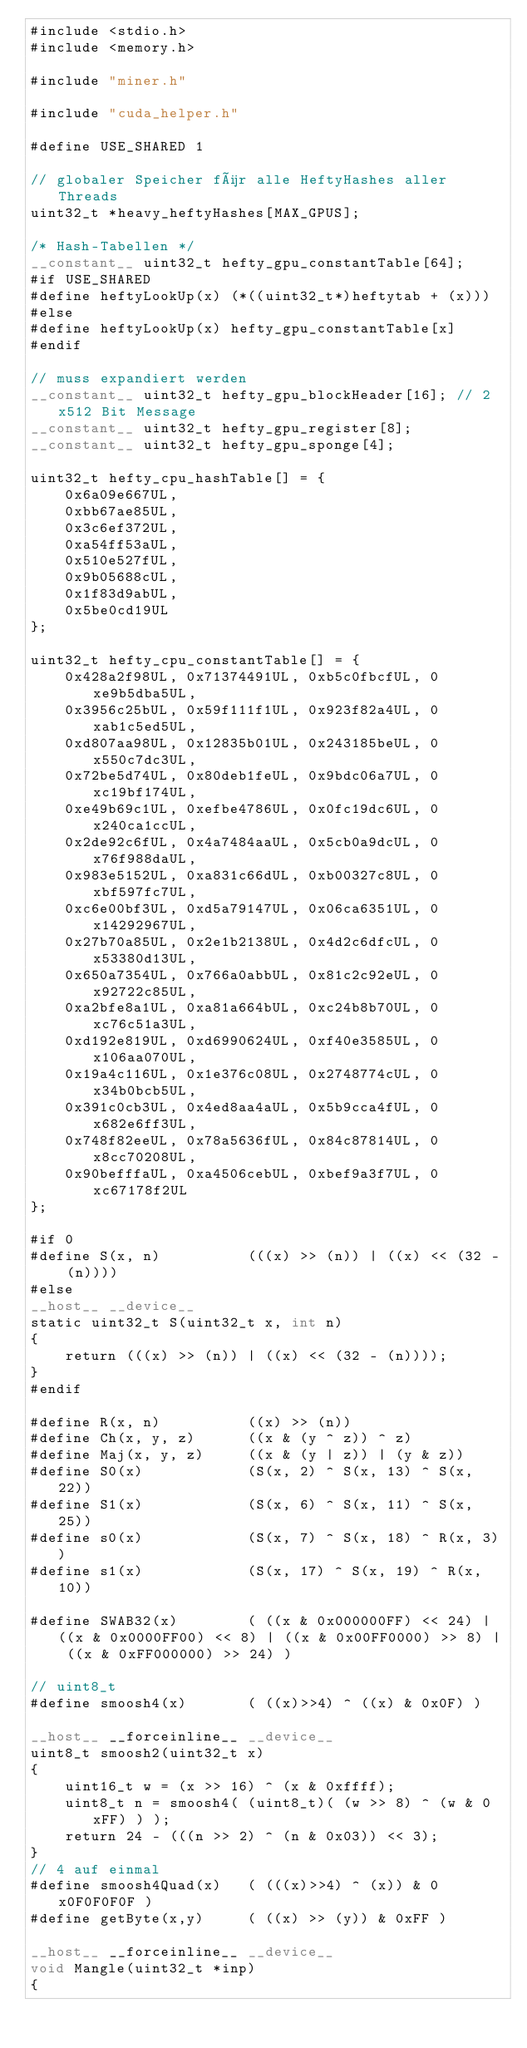<code> <loc_0><loc_0><loc_500><loc_500><_Cuda_>#include <stdio.h>
#include <memory.h>

#include "miner.h"

#include "cuda_helper.h"

#define USE_SHARED 1

// globaler Speicher für alle HeftyHashes aller Threads
uint32_t *heavy_heftyHashes[MAX_GPUS];

/* Hash-Tabellen */
__constant__ uint32_t hefty_gpu_constantTable[64];
#if USE_SHARED
#define heftyLookUp(x) (*((uint32_t*)heftytab + (x)))
#else
#define heftyLookUp(x) hefty_gpu_constantTable[x]
#endif

// muss expandiert werden
__constant__ uint32_t hefty_gpu_blockHeader[16]; // 2x512 Bit Message
__constant__ uint32_t hefty_gpu_register[8];
__constant__ uint32_t hefty_gpu_sponge[4];

uint32_t hefty_cpu_hashTable[] = {
    0x6a09e667UL,
    0xbb67ae85UL,
    0x3c6ef372UL,
    0xa54ff53aUL,
    0x510e527fUL,
    0x9b05688cUL,
    0x1f83d9abUL,
    0x5be0cd19UL
};

uint32_t hefty_cpu_constantTable[] = {
    0x428a2f98UL, 0x71374491UL, 0xb5c0fbcfUL, 0xe9b5dba5UL,
    0x3956c25bUL, 0x59f111f1UL, 0x923f82a4UL, 0xab1c5ed5UL,
    0xd807aa98UL, 0x12835b01UL, 0x243185beUL, 0x550c7dc3UL,
    0x72be5d74UL, 0x80deb1feUL, 0x9bdc06a7UL, 0xc19bf174UL,
    0xe49b69c1UL, 0xefbe4786UL, 0x0fc19dc6UL, 0x240ca1ccUL,
    0x2de92c6fUL, 0x4a7484aaUL, 0x5cb0a9dcUL, 0x76f988daUL,
    0x983e5152UL, 0xa831c66dUL, 0xb00327c8UL, 0xbf597fc7UL,
    0xc6e00bf3UL, 0xd5a79147UL, 0x06ca6351UL, 0x14292967UL,
    0x27b70a85UL, 0x2e1b2138UL, 0x4d2c6dfcUL, 0x53380d13UL,
    0x650a7354UL, 0x766a0abbUL, 0x81c2c92eUL, 0x92722c85UL,
    0xa2bfe8a1UL, 0xa81a664bUL, 0xc24b8b70UL, 0xc76c51a3UL,
    0xd192e819UL, 0xd6990624UL, 0xf40e3585UL, 0x106aa070UL,
    0x19a4c116UL, 0x1e376c08UL, 0x2748774cUL, 0x34b0bcb5UL,
    0x391c0cb3UL, 0x4ed8aa4aUL, 0x5b9cca4fUL, 0x682e6ff3UL,
    0x748f82eeUL, 0x78a5636fUL, 0x84c87814UL, 0x8cc70208UL,
    0x90befffaUL, 0xa4506cebUL, 0xbef9a3f7UL, 0xc67178f2UL
};

#if 0
#define S(x, n)          (((x) >> (n)) | ((x) << (32 - (n))))
#else
__host__ __device__
static uint32_t S(uint32_t x, int n)
{
    return (((x) >> (n)) | ((x) << (32 - (n))));
}
#endif

#define R(x, n)          ((x) >> (n))
#define Ch(x, y, z)      ((x & (y ^ z)) ^ z)
#define Maj(x, y, z)     ((x & (y | z)) | (y & z))
#define S0(x)            (S(x, 2) ^ S(x, 13) ^ S(x, 22))
#define S1(x)            (S(x, 6) ^ S(x, 11) ^ S(x, 25))
#define s0(x)            (S(x, 7) ^ S(x, 18) ^ R(x, 3))
#define s1(x)            (S(x, 17) ^ S(x, 19) ^ R(x, 10))

#define SWAB32(x)        ( ((x & 0x000000FF) << 24) | ((x & 0x0000FF00) << 8) | ((x & 0x00FF0000) >> 8) | ((x & 0xFF000000) >> 24) )

// uint8_t
#define smoosh4(x)       ( ((x)>>4) ^ ((x) & 0x0F) )

__host__ __forceinline__ __device__
uint8_t smoosh2(uint32_t x)
{
    uint16_t w = (x >> 16) ^ (x & 0xffff);
    uint8_t n = smoosh4( (uint8_t)( (w >> 8) ^ (w & 0xFF) ) );
    return 24 - (((n >> 2) ^ (n & 0x03)) << 3);
}
// 4 auf einmal
#define smoosh4Quad(x)   ( (((x)>>4) ^ (x)) & 0x0F0F0F0F )
#define getByte(x,y)     ( ((x) >> (y)) & 0xFF )

__host__ __forceinline__ __device__
void Mangle(uint32_t *inp)
{</code> 